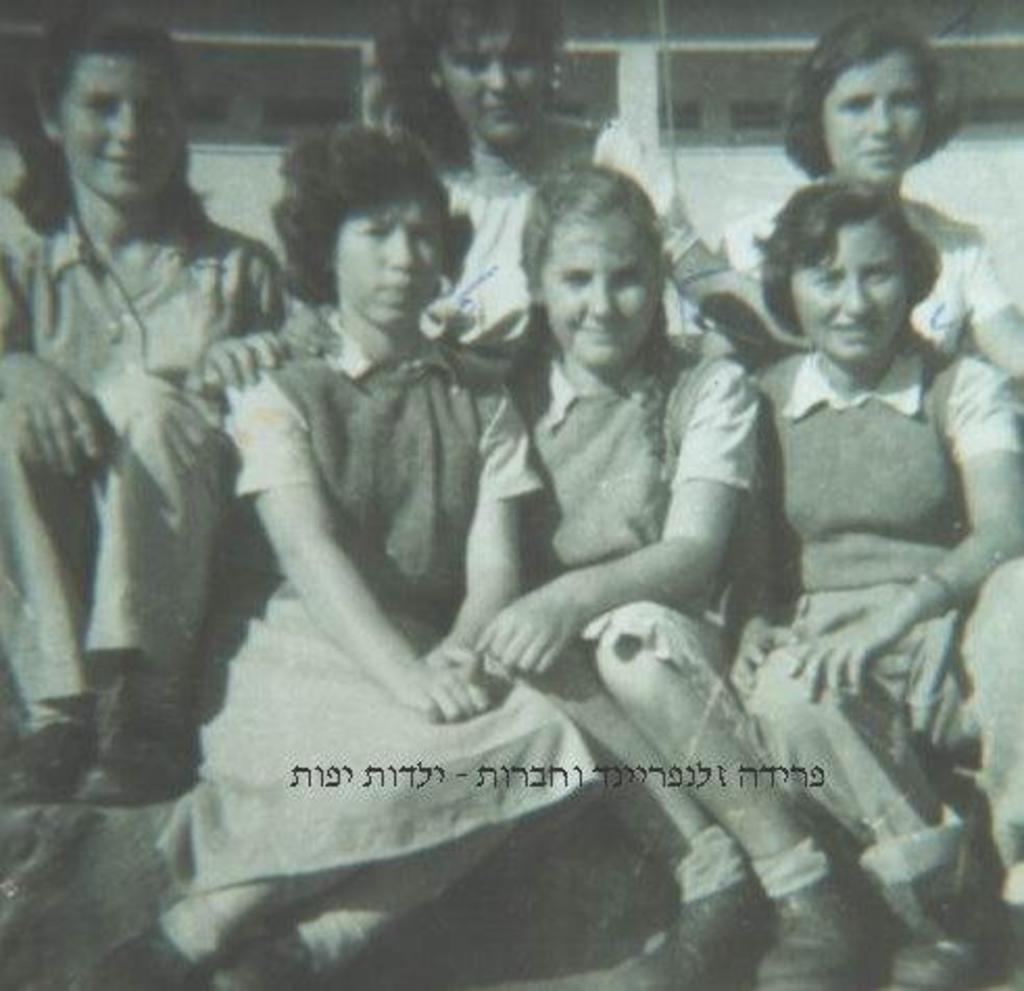What is present in the image? There are girls in the image. What are the girls doing in the image? The girls are sitting. What can be seen in the background of the image? There is a building in the background of the image. What year is depicted in the image? There is no specific year depicted in the image; it does not contain any elements that would indicate a particular time period. What type of thing is made of zinc in the image? There is no object made of zinc present in the image. 